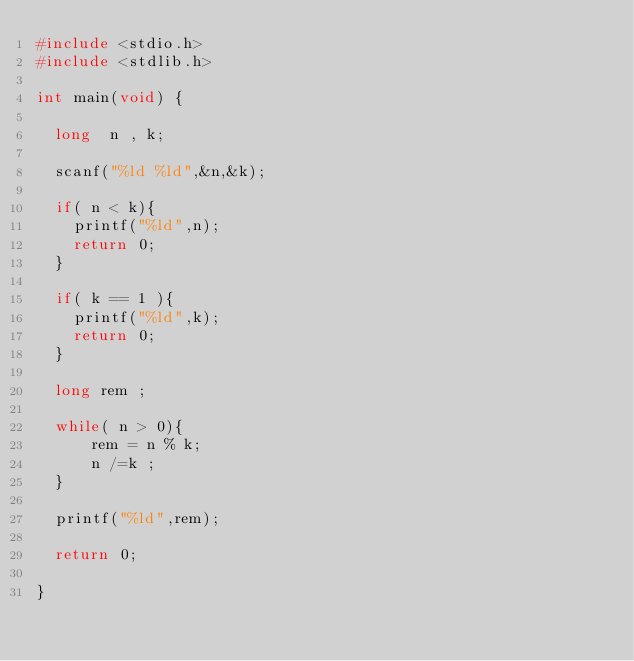Convert code to text. <code><loc_0><loc_0><loc_500><loc_500><_C_>#include <stdio.h>
#include <stdlib.h>

int main(void) {
  
  long  n , k;

  scanf("%ld %ld",&n,&k);

  if( n < k){
    printf("%ld",n);
    return 0;
  }

  if( k == 1 ){
    printf("%ld",k);
    return 0;
  }

  long rem ;

  while( n > 0){
      rem = n % k;
      n /=k ;
  }

  printf("%ld",rem);

  return 0;

}</code> 